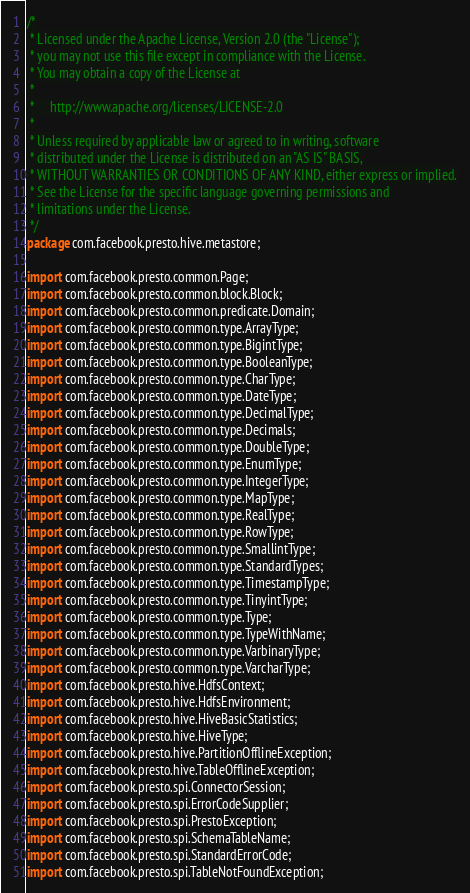Convert code to text. <code><loc_0><loc_0><loc_500><loc_500><_Java_>/*
 * Licensed under the Apache License, Version 2.0 (the "License");
 * you may not use this file except in compliance with the License.
 * You may obtain a copy of the License at
 *
 *     http://www.apache.org/licenses/LICENSE-2.0
 *
 * Unless required by applicable law or agreed to in writing, software
 * distributed under the License is distributed on an "AS IS" BASIS,
 * WITHOUT WARRANTIES OR CONDITIONS OF ANY KIND, either express or implied.
 * See the License for the specific language governing permissions and
 * limitations under the License.
 */
package com.facebook.presto.hive.metastore;

import com.facebook.presto.common.Page;
import com.facebook.presto.common.block.Block;
import com.facebook.presto.common.predicate.Domain;
import com.facebook.presto.common.type.ArrayType;
import com.facebook.presto.common.type.BigintType;
import com.facebook.presto.common.type.BooleanType;
import com.facebook.presto.common.type.CharType;
import com.facebook.presto.common.type.DateType;
import com.facebook.presto.common.type.DecimalType;
import com.facebook.presto.common.type.Decimals;
import com.facebook.presto.common.type.DoubleType;
import com.facebook.presto.common.type.EnumType;
import com.facebook.presto.common.type.IntegerType;
import com.facebook.presto.common.type.MapType;
import com.facebook.presto.common.type.RealType;
import com.facebook.presto.common.type.RowType;
import com.facebook.presto.common.type.SmallintType;
import com.facebook.presto.common.type.StandardTypes;
import com.facebook.presto.common.type.TimestampType;
import com.facebook.presto.common.type.TinyintType;
import com.facebook.presto.common.type.Type;
import com.facebook.presto.common.type.TypeWithName;
import com.facebook.presto.common.type.VarbinaryType;
import com.facebook.presto.common.type.VarcharType;
import com.facebook.presto.hive.HdfsContext;
import com.facebook.presto.hive.HdfsEnvironment;
import com.facebook.presto.hive.HiveBasicStatistics;
import com.facebook.presto.hive.HiveType;
import com.facebook.presto.hive.PartitionOfflineException;
import com.facebook.presto.hive.TableOfflineException;
import com.facebook.presto.spi.ConnectorSession;
import com.facebook.presto.spi.ErrorCodeSupplier;
import com.facebook.presto.spi.PrestoException;
import com.facebook.presto.spi.SchemaTableName;
import com.facebook.presto.spi.StandardErrorCode;
import com.facebook.presto.spi.TableNotFoundException;</code> 